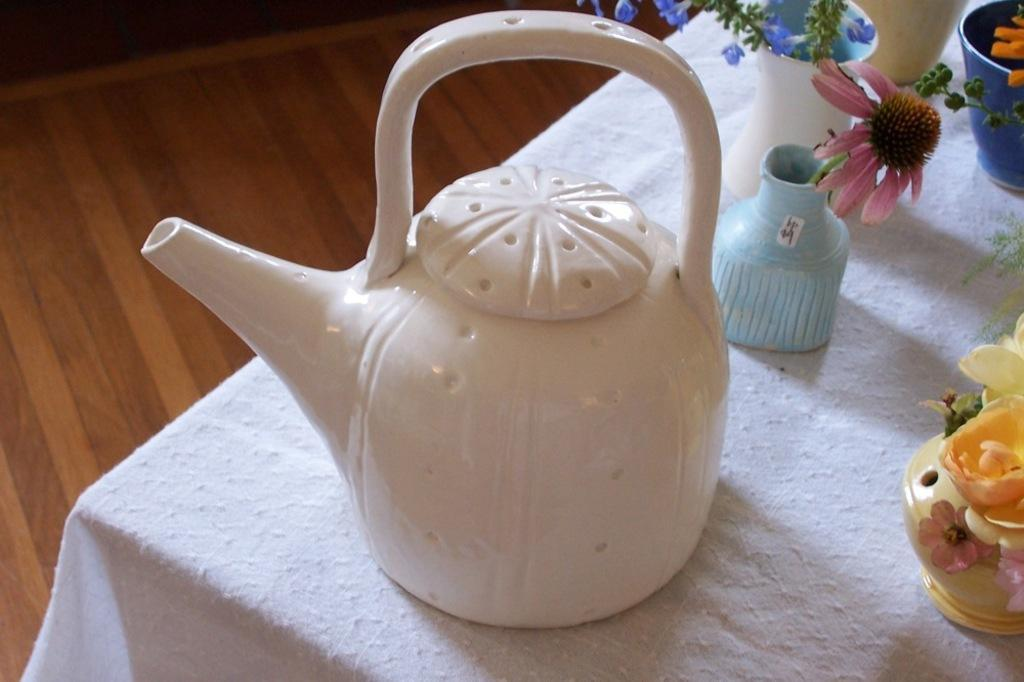What type of furniture is present in the image? There is a table in the image. What is covering the table? There is a white cloth on the table. What type of container is visible in the image? There is a jar in the image. What type of cooking or storage vessels are present in the image? There are pots in the image. What type of decorative or natural elements are present in the image? There are flowers in the image. What part of the room can be seen on the left side of the image? The floor is visible on the left side of the image. How many deer can be seen playing chess on the table in the image? There are no deer or chess game present in the image. What type of secretary is working on the table in the image? There is no secretary present in the image; it is a table with various items on it. 